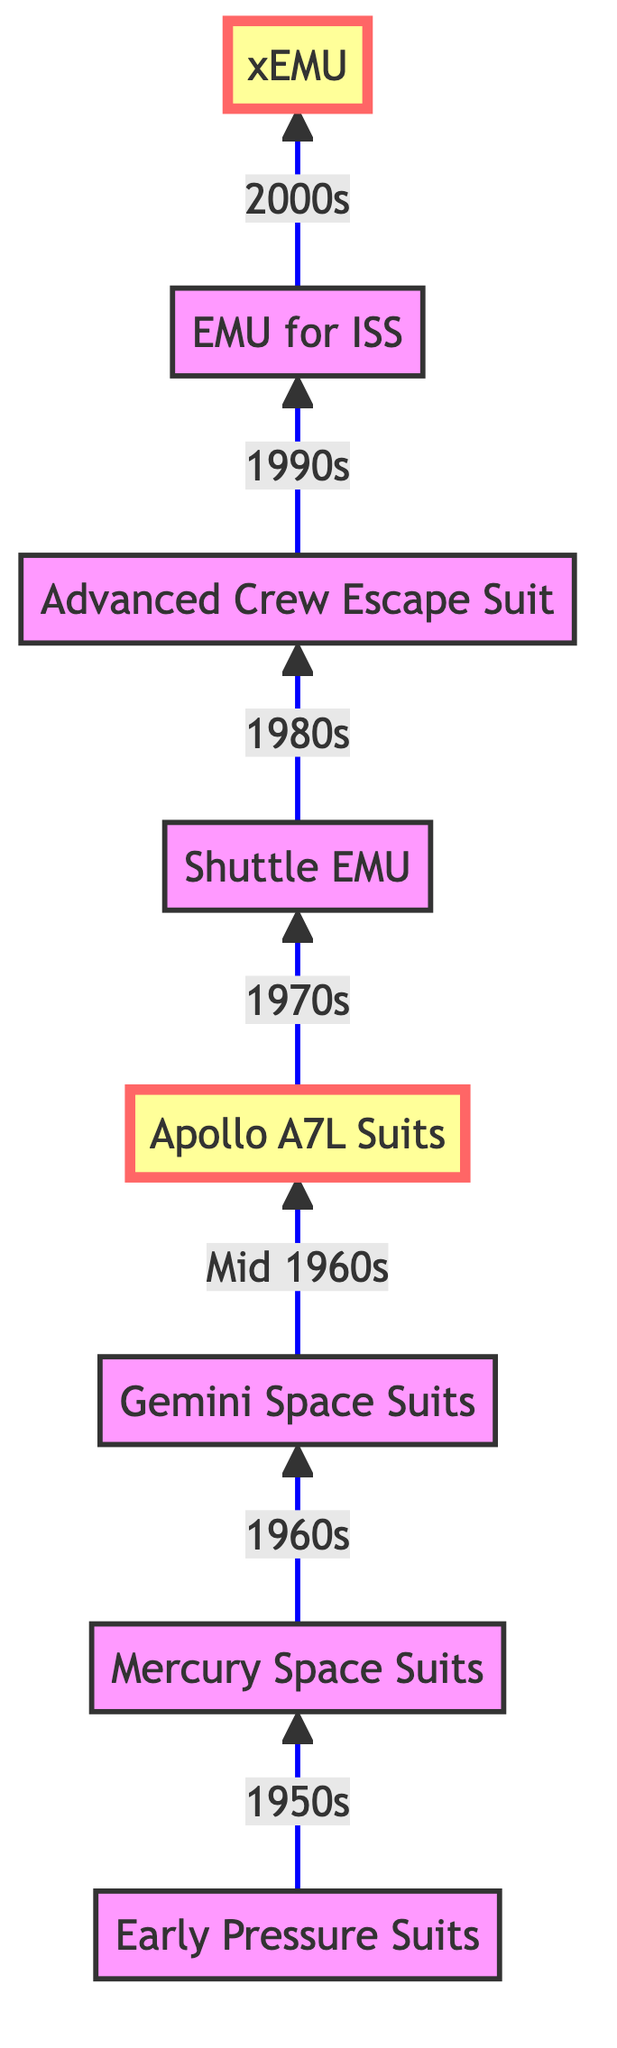What was the first type of space suit developed? The diagram indicates that the earliest type of space suit was the "Early Pressure Suits," which were built in the 1950s. This is the starting point of the flow and is labeled at the bottom of the diagram.
Answer: Early Pressure Suits Which space suit was used during the Mercury missions? According to the flowchart, the "Mercury Space Suits" are specifically designed for the Mercury missions and are positioned directly above the "Early Pressure Suits." This shows their historical sequence in the development of space suits.
Answer: Mercury Space Suits How many different types of space suits are represented in the diagram? By counting the nodes shown in the diagram, there are eight different types of space suits represented, from "Early Pressure Suits" to "xEMU." Each node corresponds to a type, indicating the progression of technology.
Answer: Eight What significant advancement is found in the Apollo A7L Suits? The Apollo A7L Suits, highlighted in the diagram, were designed to endure the harsh lunar environment and provide protection from micrometeoroids and temperature extremes. This information can be derived from both the description of the node and its position in the diagram's flow.
Answer: Protection from micrometeoroids What space suit followed the Apollo A7L Suits in the timeline? The diagram shows a direct arrow pointing from "Apollo A7L Suits" to "Shuttle EMU," indicating that the Shuttle Extravehicular Mobility Unit came after the Apollo suits in the chronological progression of space suit technology.
Answer: Shuttle EMU Which space suit was designed with emergency features for Shuttle launches in the 1990s? The "Advanced Crew Escape Suit" is explicitly mentioned in the diagram as the suit designed for emergency situations during Shuttle launches in the 1990s, which links it to that specific time and function.
Answer: Advanced Crew Escape Suit What does the "xEMU" stand for? The node labeled "xEMU" in the diagram describes it as the "Exploration Extravehicular Mobility Unit," which is crucial for future lunar and Mars missions, according to the diagram's description.
Answer: Exploration Extravehicular Mobility Unit How have the suits evolved in terms of mobility? The diagram traces a clear evolution from "Mercury Space Suits," which improved mobility, to "xEMU," which features advanced mobility and modularity for different mission scenarios, showing continuous improvements in this aspect across the timeline.
Answer: Advanced mobility 